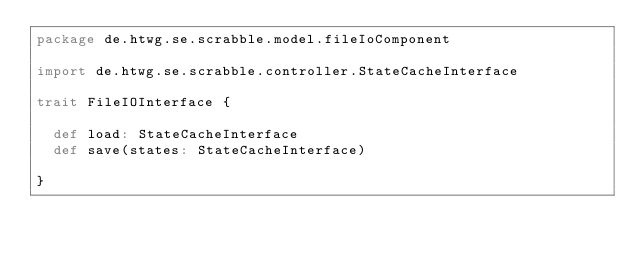<code> <loc_0><loc_0><loc_500><loc_500><_Scala_>package de.htwg.se.scrabble.model.fileIoComponent

import de.htwg.se.scrabble.controller.StateCacheInterface

trait FileIOInterface {

  def load: StateCacheInterface
  def save(states: StateCacheInterface)

}
</code> 